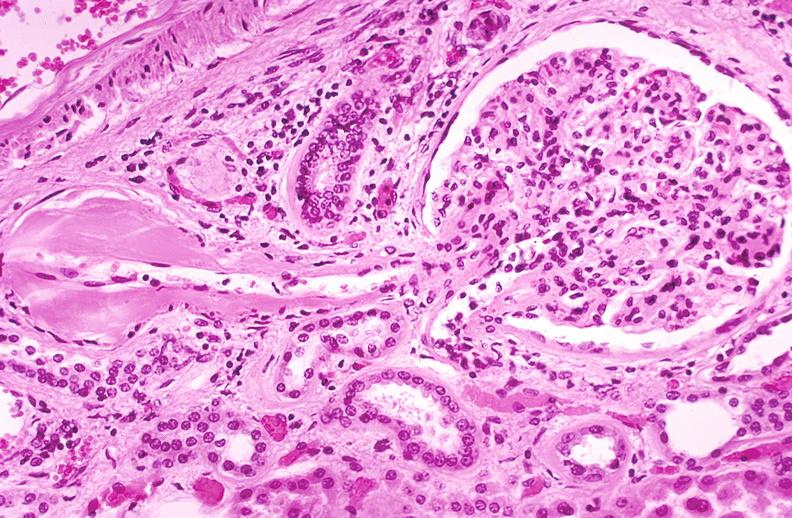what does this image show?
Answer the question using a single word or phrase. Kidney glomerulus 